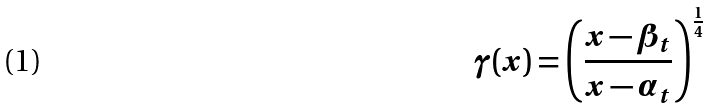Convert formula to latex. <formula><loc_0><loc_0><loc_500><loc_500>\gamma ( x ) = \left ( \frac { x - \beta _ { t } } { x - \alpha _ { t } } \right ) ^ { \frac { 1 } { 4 } }</formula> 